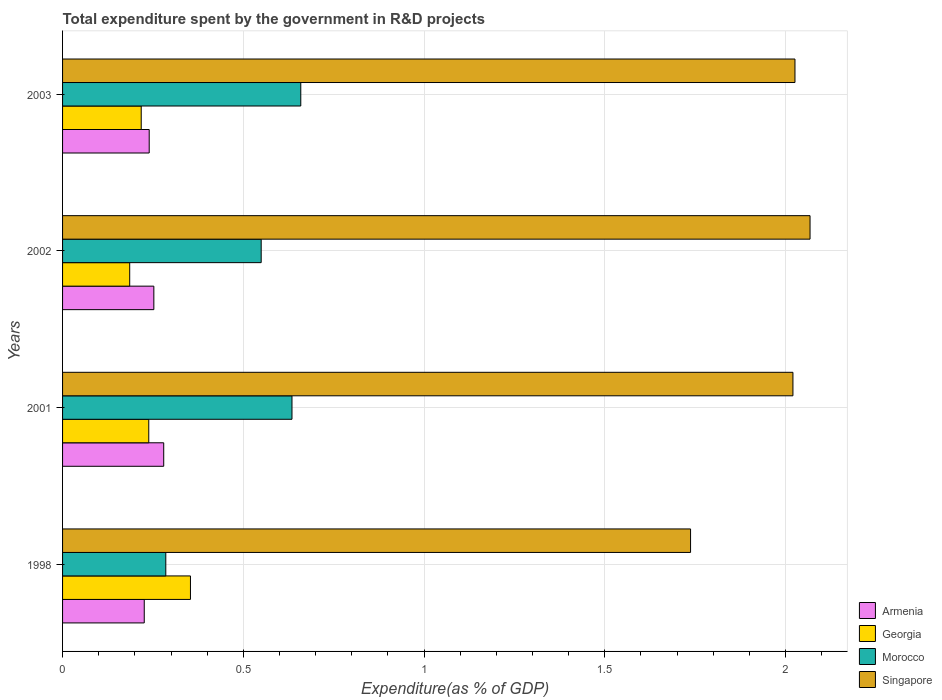How many different coloured bars are there?
Offer a very short reply. 4. How many groups of bars are there?
Your response must be concise. 4. Are the number of bars per tick equal to the number of legend labels?
Offer a very short reply. Yes. Are the number of bars on each tick of the Y-axis equal?
Keep it short and to the point. Yes. What is the label of the 4th group of bars from the top?
Your answer should be compact. 1998. What is the total expenditure spent by the government in R&D projects in Morocco in 2003?
Provide a short and direct response. 0.66. Across all years, what is the maximum total expenditure spent by the government in R&D projects in Singapore?
Offer a terse response. 2.07. Across all years, what is the minimum total expenditure spent by the government in R&D projects in Morocco?
Make the answer very short. 0.29. In which year was the total expenditure spent by the government in R&D projects in Singapore maximum?
Give a very brief answer. 2002. What is the total total expenditure spent by the government in R&D projects in Morocco in the graph?
Your answer should be compact. 2.13. What is the difference between the total expenditure spent by the government in R&D projects in Morocco in 2001 and that in 2002?
Offer a terse response. 0.09. What is the difference between the total expenditure spent by the government in R&D projects in Georgia in 1998 and the total expenditure spent by the government in R&D projects in Singapore in 2002?
Make the answer very short. -1.71. What is the average total expenditure spent by the government in R&D projects in Georgia per year?
Your answer should be compact. 0.25. In the year 2002, what is the difference between the total expenditure spent by the government in R&D projects in Armenia and total expenditure spent by the government in R&D projects in Morocco?
Provide a short and direct response. -0.3. In how many years, is the total expenditure spent by the government in R&D projects in Georgia greater than 1.1 %?
Keep it short and to the point. 0. What is the ratio of the total expenditure spent by the government in R&D projects in Morocco in 2001 to that in 2003?
Offer a very short reply. 0.96. Is the total expenditure spent by the government in R&D projects in Georgia in 2002 less than that in 2003?
Ensure brevity in your answer.  Yes. Is the difference between the total expenditure spent by the government in R&D projects in Armenia in 1998 and 2002 greater than the difference between the total expenditure spent by the government in R&D projects in Morocco in 1998 and 2002?
Your answer should be very brief. Yes. What is the difference between the highest and the second highest total expenditure spent by the government in R&D projects in Georgia?
Your answer should be compact. 0.12. What is the difference between the highest and the lowest total expenditure spent by the government in R&D projects in Morocco?
Keep it short and to the point. 0.37. Is the sum of the total expenditure spent by the government in R&D projects in Armenia in 1998 and 2002 greater than the maximum total expenditure spent by the government in R&D projects in Georgia across all years?
Provide a succinct answer. Yes. Is it the case that in every year, the sum of the total expenditure spent by the government in R&D projects in Singapore and total expenditure spent by the government in R&D projects in Georgia is greater than the sum of total expenditure spent by the government in R&D projects in Morocco and total expenditure spent by the government in R&D projects in Armenia?
Provide a short and direct response. Yes. What does the 2nd bar from the top in 2001 represents?
Keep it short and to the point. Morocco. What does the 1st bar from the bottom in 2001 represents?
Provide a succinct answer. Armenia. Is it the case that in every year, the sum of the total expenditure spent by the government in R&D projects in Georgia and total expenditure spent by the government in R&D projects in Singapore is greater than the total expenditure spent by the government in R&D projects in Morocco?
Offer a very short reply. Yes. How many bars are there?
Ensure brevity in your answer.  16. Are all the bars in the graph horizontal?
Your response must be concise. Yes. Are the values on the major ticks of X-axis written in scientific E-notation?
Give a very brief answer. No. Does the graph contain grids?
Give a very brief answer. Yes. Where does the legend appear in the graph?
Make the answer very short. Bottom right. How are the legend labels stacked?
Provide a short and direct response. Vertical. What is the title of the graph?
Give a very brief answer. Total expenditure spent by the government in R&D projects. Does "Isle of Man" appear as one of the legend labels in the graph?
Your answer should be very brief. No. What is the label or title of the X-axis?
Your answer should be very brief. Expenditure(as % of GDP). What is the Expenditure(as % of GDP) in Armenia in 1998?
Keep it short and to the point. 0.23. What is the Expenditure(as % of GDP) of Georgia in 1998?
Your answer should be very brief. 0.35. What is the Expenditure(as % of GDP) of Morocco in 1998?
Keep it short and to the point. 0.29. What is the Expenditure(as % of GDP) of Singapore in 1998?
Your answer should be very brief. 1.74. What is the Expenditure(as % of GDP) in Armenia in 2001?
Your response must be concise. 0.28. What is the Expenditure(as % of GDP) in Georgia in 2001?
Offer a terse response. 0.24. What is the Expenditure(as % of GDP) of Morocco in 2001?
Offer a very short reply. 0.63. What is the Expenditure(as % of GDP) of Singapore in 2001?
Your answer should be very brief. 2.02. What is the Expenditure(as % of GDP) of Armenia in 2002?
Make the answer very short. 0.25. What is the Expenditure(as % of GDP) of Georgia in 2002?
Ensure brevity in your answer.  0.19. What is the Expenditure(as % of GDP) in Morocco in 2002?
Offer a very short reply. 0.55. What is the Expenditure(as % of GDP) of Singapore in 2002?
Give a very brief answer. 2.07. What is the Expenditure(as % of GDP) in Armenia in 2003?
Keep it short and to the point. 0.24. What is the Expenditure(as % of GDP) of Georgia in 2003?
Your answer should be compact. 0.22. What is the Expenditure(as % of GDP) of Morocco in 2003?
Make the answer very short. 0.66. What is the Expenditure(as % of GDP) in Singapore in 2003?
Your answer should be very brief. 2.03. Across all years, what is the maximum Expenditure(as % of GDP) of Armenia?
Your answer should be very brief. 0.28. Across all years, what is the maximum Expenditure(as % of GDP) of Georgia?
Keep it short and to the point. 0.35. Across all years, what is the maximum Expenditure(as % of GDP) of Morocco?
Keep it short and to the point. 0.66. Across all years, what is the maximum Expenditure(as % of GDP) in Singapore?
Provide a succinct answer. 2.07. Across all years, what is the minimum Expenditure(as % of GDP) in Armenia?
Offer a terse response. 0.23. Across all years, what is the minimum Expenditure(as % of GDP) in Georgia?
Ensure brevity in your answer.  0.19. Across all years, what is the minimum Expenditure(as % of GDP) in Morocco?
Make the answer very short. 0.29. Across all years, what is the minimum Expenditure(as % of GDP) of Singapore?
Make the answer very short. 1.74. What is the total Expenditure(as % of GDP) of Morocco in the graph?
Make the answer very short. 2.13. What is the total Expenditure(as % of GDP) in Singapore in the graph?
Your response must be concise. 7.85. What is the difference between the Expenditure(as % of GDP) in Armenia in 1998 and that in 2001?
Make the answer very short. -0.05. What is the difference between the Expenditure(as % of GDP) of Georgia in 1998 and that in 2001?
Offer a very short reply. 0.12. What is the difference between the Expenditure(as % of GDP) in Morocco in 1998 and that in 2001?
Ensure brevity in your answer.  -0.35. What is the difference between the Expenditure(as % of GDP) of Singapore in 1998 and that in 2001?
Provide a short and direct response. -0.28. What is the difference between the Expenditure(as % of GDP) of Armenia in 1998 and that in 2002?
Ensure brevity in your answer.  -0.03. What is the difference between the Expenditure(as % of GDP) in Georgia in 1998 and that in 2002?
Your answer should be very brief. 0.17. What is the difference between the Expenditure(as % of GDP) in Morocco in 1998 and that in 2002?
Provide a short and direct response. -0.26. What is the difference between the Expenditure(as % of GDP) in Singapore in 1998 and that in 2002?
Make the answer very short. -0.33. What is the difference between the Expenditure(as % of GDP) of Armenia in 1998 and that in 2003?
Offer a very short reply. -0.01. What is the difference between the Expenditure(as % of GDP) in Georgia in 1998 and that in 2003?
Make the answer very short. 0.14. What is the difference between the Expenditure(as % of GDP) in Morocco in 1998 and that in 2003?
Your answer should be compact. -0.37. What is the difference between the Expenditure(as % of GDP) of Singapore in 1998 and that in 2003?
Your response must be concise. -0.29. What is the difference between the Expenditure(as % of GDP) in Armenia in 2001 and that in 2002?
Provide a succinct answer. 0.03. What is the difference between the Expenditure(as % of GDP) in Georgia in 2001 and that in 2002?
Provide a succinct answer. 0.05. What is the difference between the Expenditure(as % of GDP) in Morocco in 2001 and that in 2002?
Provide a short and direct response. 0.09. What is the difference between the Expenditure(as % of GDP) in Singapore in 2001 and that in 2002?
Make the answer very short. -0.05. What is the difference between the Expenditure(as % of GDP) in Armenia in 2001 and that in 2003?
Your answer should be very brief. 0.04. What is the difference between the Expenditure(as % of GDP) of Georgia in 2001 and that in 2003?
Offer a terse response. 0.02. What is the difference between the Expenditure(as % of GDP) of Morocco in 2001 and that in 2003?
Provide a succinct answer. -0.02. What is the difference between the Expenditure(as % of GDP) in Singapore in 2001 and that in 2003?
Offer a very short reply. -0.01. What is the difference between the Expenditure(as % of GDP) of Armenia in 2002 and that in 2003?
Your answer should be compact. 0.01. What is the difference between the Expenditure(as % of GDP) in Georgia in 2002 and that in 2003?
Your response must be concise. -0.03. What is the difference between the Expenditure(as % of GDP) in Morocco in 2002 and that in 2003?
Your answer should be compact. -0.11. What is the difference between the Expenditure(as % of GDP) in Singapore in 2002 and that in 2003?
Provide a short and direct response. 0.04. What is the difference between the Expenditure(as % of GDP) of Armenia in 1998 and the Expenditure(as % of GDP) of Georgia in 2001?
Provide a short and direct response. -0.01. What is the difference between the Expenditure(as % of GDP) of Armenia in 1998 and the Expenditure(as % of GDP) of Morocco in 2001?
Offer a terse response. -0.41. What is the difference between the Expenditure(as % of GDP) in Armenia in 1998 and the Expenditure(as % of GDP) in Singapore in 2001?
Offer a terse response. -1.79. What is the difference between the Expenditure(as % of GDP) of Georgia in 1998 and the Expenditure(as % of GDP) of Morocco in 2001?
Provide a short and direct response. -0.28. What is the difference between the Expenditure(as % of GDP) in Georgia in 1998 and the Expenditure(as % of GDP) in Singapore in 2001?
Offer a terse response. -1.67. What is the difference between the Expenditure(as % of GDP) in Morocco in 1998 and the Expenditure(as % of GDP) in Singapore in 2001?
Give a very brief answer. -1.74. What is the difference between the Expenditure(as % of GDP) in Armenia in 1998 and the Expenditure(as % of GDP) in Georgia in 2002?
Keep it short and to the point. 0.04. What is the difference between the Expenditure(as % of GDP) in Armenia in 1998 and the Expenditure(as % of GDP) in Morocco in 2002?
Make the answer very short. -0.32. What is the difference between the Expenditure(as % of GDP) in Armenia in 1998 and the Expenditure(as % of GDP) in Singapore in 2002?
Your response must be concise. -1.84. What is the difference between the Expenditure(as % of GDP) in Georgia in 1998 and the Expenditure(as % of GDP) in Morocco in 2002?
Provide a succinct answer. -0.2. What is the difference between the Expenditure(as % of GDP) in Georgia in 1998 and the Expenditure(as % of GDP) in Singapore in 2002?
Ensure brevity in your answer.  -1.71. What is the difference between the Expenditure(as % of GDP) of Morocco in 1998 and the Expenditure(as % of GDP) of Singapore in 2002?
Your answer should be compact. -1.78. What is the difference between the Expenditure(as % of GDP) in Armenia in 1998 and the Expenditure(as % of GDP) in Georgia in 2003?
Give a very brief answer. 0.01. What is the difference between the Expenditure(as % of GDP) in Armenia in 1998 and the Expenditure(as % of GDP) in Morocco in 2003?
Your response must be concise. -0.43. What is the difference between the Expenditure(as % of GDP) in Armenia in 1998 and the Expenditure(as % of GDP) in Singapore in 2003?
Ensure brevity in your answer.  -1.8. What is the difference between the Expenditure(as % of GDP) of Georgia in 1998 and the Expenditure(as % of GDP) of Morocco in 2003?
Offer a terse response. -0.31. What is the difference between the Expenditure(as % of GDP) in Georgia in 1998 and the Expenditure(as % of GDP) in Singapore in 2003?
Offer a terse response. -1.67. What is the difference between the Expenditure(as % of GDP) of Morocco in 1998 and the Expenditure(as % of GDP) of Singapore in 2003?
Keep it short and to the point. -1.74. What is the difference between the Expenditure(as % of GDP) of Armenia in 2001 and the Expenditure(as % of GDP) of Georgia in 2002?
Offer a very short reply. 0.09. What is the difference between the Expenditure(as % of GDP) in Armenia in 2001 and the Expenditure(as % of GDP) in Morocco in 2002?
Give a very brief answer. -0.27. What is the difference between the Expenditure(as % of GDP) in Armenia in 2001 and the Expenditure(as % of GDP) in Singapore in 2002?
Your response must be concise. -1.79. What is the difference between the Expenditure(as % of GDP) of Georgia in 2001 and the Expenditure(as % of GDP) of Morocco in 2002?
Offer a very short reply. -0.31. What is the difference between the Expenditure(as % of GDP) of Georgia in 2001 and the Expenditure(as % of GDP) of Singapore in 2002?
Make the answer very short. -1.83. What is the difference between the Expenditure(as % of GDP) of Morocco in 2001 and the Expenditure(as % of GDP) of Singapore in 2002?
Your answer should be very brief. -1.43. What is the difference between the Expenditure(as % of GDP) of Armenia in 2001 and the Expenditure(as % of GDP) of Georgia in 2003?
Ensure brevity in your answer.  0.06. What is the difference between the Expenditure(as % of GDP) in Armenia in 2001 and the Expenditure(as % of GDP) in Morocco in 2003?
Keep it short and to the point. -0.38. What is the difference between the Expenditure(as % of GDP) of Armenia in 2001 and the Expenditure(as % of GDP) of Singapore in 2003?
Provide a short and direct response. -1.75. What is the difference between the Expenditure(as % of GDP) of Georgia in 2001 and the Expenditure(as % of GDP) of Morocco in 2003?
Provide a succinct answer. -0.42. What is the difference between the Expenditure(as % of GDP) in Georgia in 2001 and the Expenditure(as % of GDP) in Singapore in 2003?
Give a very brief answer. -1.79. What is the difference between the Expenditure(as % of GDP) in Morocco in 2001 and the Expenditure(as % of GDP) in Singapore in 2003?
Your answer should be very brief. -1.39. What is the difference between the Expenditure(as % of GDP) of Armenia in 2002 and the Expenditure(as % of GDP) of Georgia in 2003?
Offer a terse response. 0.04. What is the difference between the Expenditure(as % of GDP) of Armenia in 2002 and the Expenditure(as % of GDP) of Morocco in 2003?
Provide a succinct answer. -0.41. What is the difference between the Expenditure(as % of GDP) of Armenia in 2002 and the Expenditure(as % of GDP) of Singapore in 2003?
Your response must be concise. -1.77. What is the difference between the Expenditure(as % of GDP) in Georgia in 2002 and the Expenditure(as % of GDP) in Morocco in 2003?
Your response must be concise. -0.47. What is the difference between the Expenditure(as % of GDP) of Georgia in 2002 and the Expenditure(as % of GDP) of Singapore in 2003?
Give a very brief answer. -1.84. What is the difference between the Expenditure(as % of GDP) in Morocco in 2002 and the Expenditure(as % of GDP) in Singapore in 2003?
Offer a very short reply. -1.48. What is the average Expenditure(as % of GDP) in Armenia per year?
Offer a very short reply. 0.25. What is the average Expenditure(as % of GDP) in Georgia per year?
Ensure brevity in your answer.  0.25. What is the average Expenditure(as % of GDP) in Morocco per year?
Your answer should be very brief. 0.53. What is the average Expenditure(as % of GDP) of Singapore per year?
Ensure brevity in your answer.  1.96. In the year 1998, what is the difference between the Expenditure(as % of GDP) of Armenia and Expenditure(as % of GDP) of Georgia?
Ensure brevity in your answer.  -0.13. In the year 1998, what is the difference between the Expenditure(as % of GDP) of Armenia and Expenditure(as % of GDP) of Morocco?
Provide a succinct answer. -0.06. In the year 1998, what is the difference between the Expenditure(as % of GDP) in Armenia and Expenditure(as % of GDP) in Singapore?
Provide a succinct answer. -1.51. In the year 1998, what is the difference between the Expenditure(as % of GDP) in Georgia and Expenditure(as % of GDP) in Morocco?
Your answer should be compact. 0.07. In the year 1998, what is the difference between the Expenditure(as % of GDP) in Georgia and Expenditure(as % of GDP) in Singapore?
Provide a succinct answer. -1.38. In the year 1998, what is the difference between the Expenditure(as % of GDP) of Morocco and Expenditure(as % of GDP) of Singapore?
Your answer should be compact. -1.45. In the year 2001, what is the difference between the Expenditure(as % of GDP) of Armenia and Expenditure(as % of GDP) of Georgia?
Make the answer very short. 0.04. In the year 2001, what is the difference between the Expenditure(as % of GDP) in Armenia and Expenditure(as % of GDP) in Morocco?
Offer a very short reply. -0.35. In the year 2001, what is the difference between the Expenditure(as % of GDP) of Armenia and Expenditure(as % of GDP) of Singapore?
Offer a terse response. -1.74. In the year 2001, what is the difference between the Expenditure(as % of GDP) in Georgia and Expenditure(as % of GDP) in Morocco?
Provide a succinct answer. -0.4. In the year 2001, what is the difference between the Expenditure(as % of GDP) in Georgia and Expenditure(as % of GDP) in Singapore?
Provide a succinct answer. -1.78. In the year 2001, what is the difference between the Expenditure(as % of GDP) of Morocco and Expenditure(as % of GDP) of Singapore?
Ensure brevity in your answer.  -1.39. In the year 2002, what is the difference between the Expenditure(as % of GDP) in Armenia and Expenditure(as % of GDP) in Georgia?
Offer a very short reply. 0.07. In the year 2002, what is the difference between the Expenditure(as % of GDP) in Armenia and Expenditure(as % of GDP) in Morocco?
Your response must be concise. -0.3. In the year 2002, what is the difference between the Expenditure(as % of GDP) in Armenia and Expenditure(as % of GDP) in Singapore?
Your answer should be compact. -1.82. In the year 2002, what is the difference between the Expenditure(as % of GDP) of Georgia and Expenditure(as % of GDP) of Morocco?
Give a very brief answer. -0.36. In the year 2002, what is the difference between the Expenditure(as % of GDP) of Georgia and Expenditure(as % of GDP) of Singapore?
Give a very brief answer. -1.88. In the year 2002, what is the difference between the Expenditure(as % of GDP) in Morocco and Expenditure(as % of GDP) in Singapore?
Offer a terse response. -1.52. In the year 2003, what is the difference between the Expenditure(as % of GDP) of Armenia and Expenditure(as % of GDP) of Georgia?
Your answer should be very brief. 0.02. In the year 2003, what is the difference between the Expenditure(as % of GDP) in Armenia and Expenditure(as % of GDP) in Morocco?
Offer a very short reply. -0.42. In the year 2003, what is the difference between the Expenditure(as % of GDP) of Armenia and Expenditure(as % of GDP) of Singapore?
Your answer should be compact. -1.79. In the year 2003, what is the difference between the Expenditure(as % of GDP) in Georgia and Expenditure(as % of GDP) in Morocco?
Offer a very short reply. -0.44. In the year 2003, what is the difference between the Expenditure(as % of GDP) in Georgia and Expenditure(as % of GDP) in Singapore?
Offer a terse response. -1.81. In the year 2003, what is the difference between the Expenditure(as % of GDP) of Morocco and Expenditure(as % of GDP) of Singapore?
Your response must be concise. -1.37. What is the ratio of the Expenditure(as % of GDP) of Armenia in 1998 to that in 2001?
Provide a succinct answer. 0.81. What is the ratio of the Expenditure(as % of GDP) of Georgia in 1998 to that in 2001?
Your answer should be very brief. 1.48. What is the ratio of the Expenditure(as % of GDP) in Morocco in 1998 to that in 2001?
Make the answer very short. 0.45. What is the ratio of the Expenditure(as % of GDP) of Singapore in 1998 to that in 2001?
Your response must be concise. 0.86. What is the ratio of the Expenditure(as % of GDP) of Armenia in 1998 to that in 2002?
Ensure brevity in your answer.  0.89. What is the ratio of the Expenditure(as % of GDP) in Georgia in 1998 to that in 2002?
Ensure brevity in your answer.  1.91. What is the ratio of the Expenditure(as % of GDP) of Morocco in 1998 to that in 2002?
Make the answer very short. 0.52. What is the ratio of the Expenditure(as % of GDP) of Singapore in 1998 to that in 2002?
Make the answer very short. 0.84. What is the ratio of the Expenditure(as % of GDP) of Armenia in 1998 to that in 2003?
Provide a short and direct response. 0.94. What is the ratio of the Expenditure(as % of GDP) in Georgia in 1998 to that in 2003?
Provide a succinct answer. 1.63. What is the ratio of the Expenditure(as % of GDP) in Morocco in 1998 to that in 2003?
Your response must be concise. 0.43. What is the ratio of the Expenditure(as % of GDP) in Singapore in 1998 to that in 2003?
Offer a terse response. 0.86. What is the ratio of the Expenditure(as % of GDP) in Armenia in 2001 to that in 2002?
Provide a short and direct response. 1.11. What is the ratio of the Expenditure(as % of GDP) of Georgia in 2001 to that in 2002?
Offer a terse response. 1.28. What is the ratio of the Expenditure(as % of GDP) of Morocco in 2001 to that in 2002?
Offer a terse response. 1.16. What is the ratio of the Expenditure(as % of GDP) in Singapore in 2001 to that in 2002?
Your answer should be compact. 0.98. What is the ratio of the Expenditure(as % of GDP) of Armenia in 2001 to that in 2003?
Offer a very short reply. 1.17. What is the ratio of the Expenditure(as % of GDP) of Georgia in 2001 to that in 2003?
Make the answer very short. 1.1. What is the ratio of the Expenditure(as % of GDP) in Morocco in 2001 to that in 2003?
Your answer should be very brief. 0.96. What is the ratio of the Expenditure(as % of GDP) of Armenia in 2002 to that in 2003?
Offer a terse response. 1.05. What is the ratio of the Expenditure(as % of GDP) in Georgia in 2002 to that in 2003?
Make the answer very short. 0.85. What is the ratio of the Expenditure(as % of GDP) of Morocco in 2002 to that in 2003?
Your answer should be compact. 0.83. What is the ratio of the Expenditure(as % of GDP) in Singapore in 2002 to that in 2003?
Make the answer very short. 1.02. What is the difference between the highest and the second highest Expenditure(as % of GDP) in Armenia?
Your answer should be compact. 0.03. What is the difference between the highest and the second highest Expenditure(as % of GDP) in Georgia?
Your response must be concise. 0.12. What is the difference between the highest and the second highest Expenditure(as % of GDP) of Morocco?
Your answer should be very brief. 0.02. What is the difference between the highest and the second highest Expenditure(as % of GDP) of Singapore?
Provide a succinct answer. 0.04. What is the difference between the highest and the lowest Expenditure(as % of GDP) of Armenia?
Your answer should be very brief. 0.05. What is the difference between the highest and the lowest Expenditure(as % of GDP) in Georgia?
Give a very brief answer. 0.17. What is the difference between the highest and the lowest Expenditure(as % of GDP) of Morocco?
Provide a succinct answer. 0.37. What is the difference between the highest and the lowest Expenditure(as % of GDP) in Singapore?
Your answer should be very brief. 0.33. 